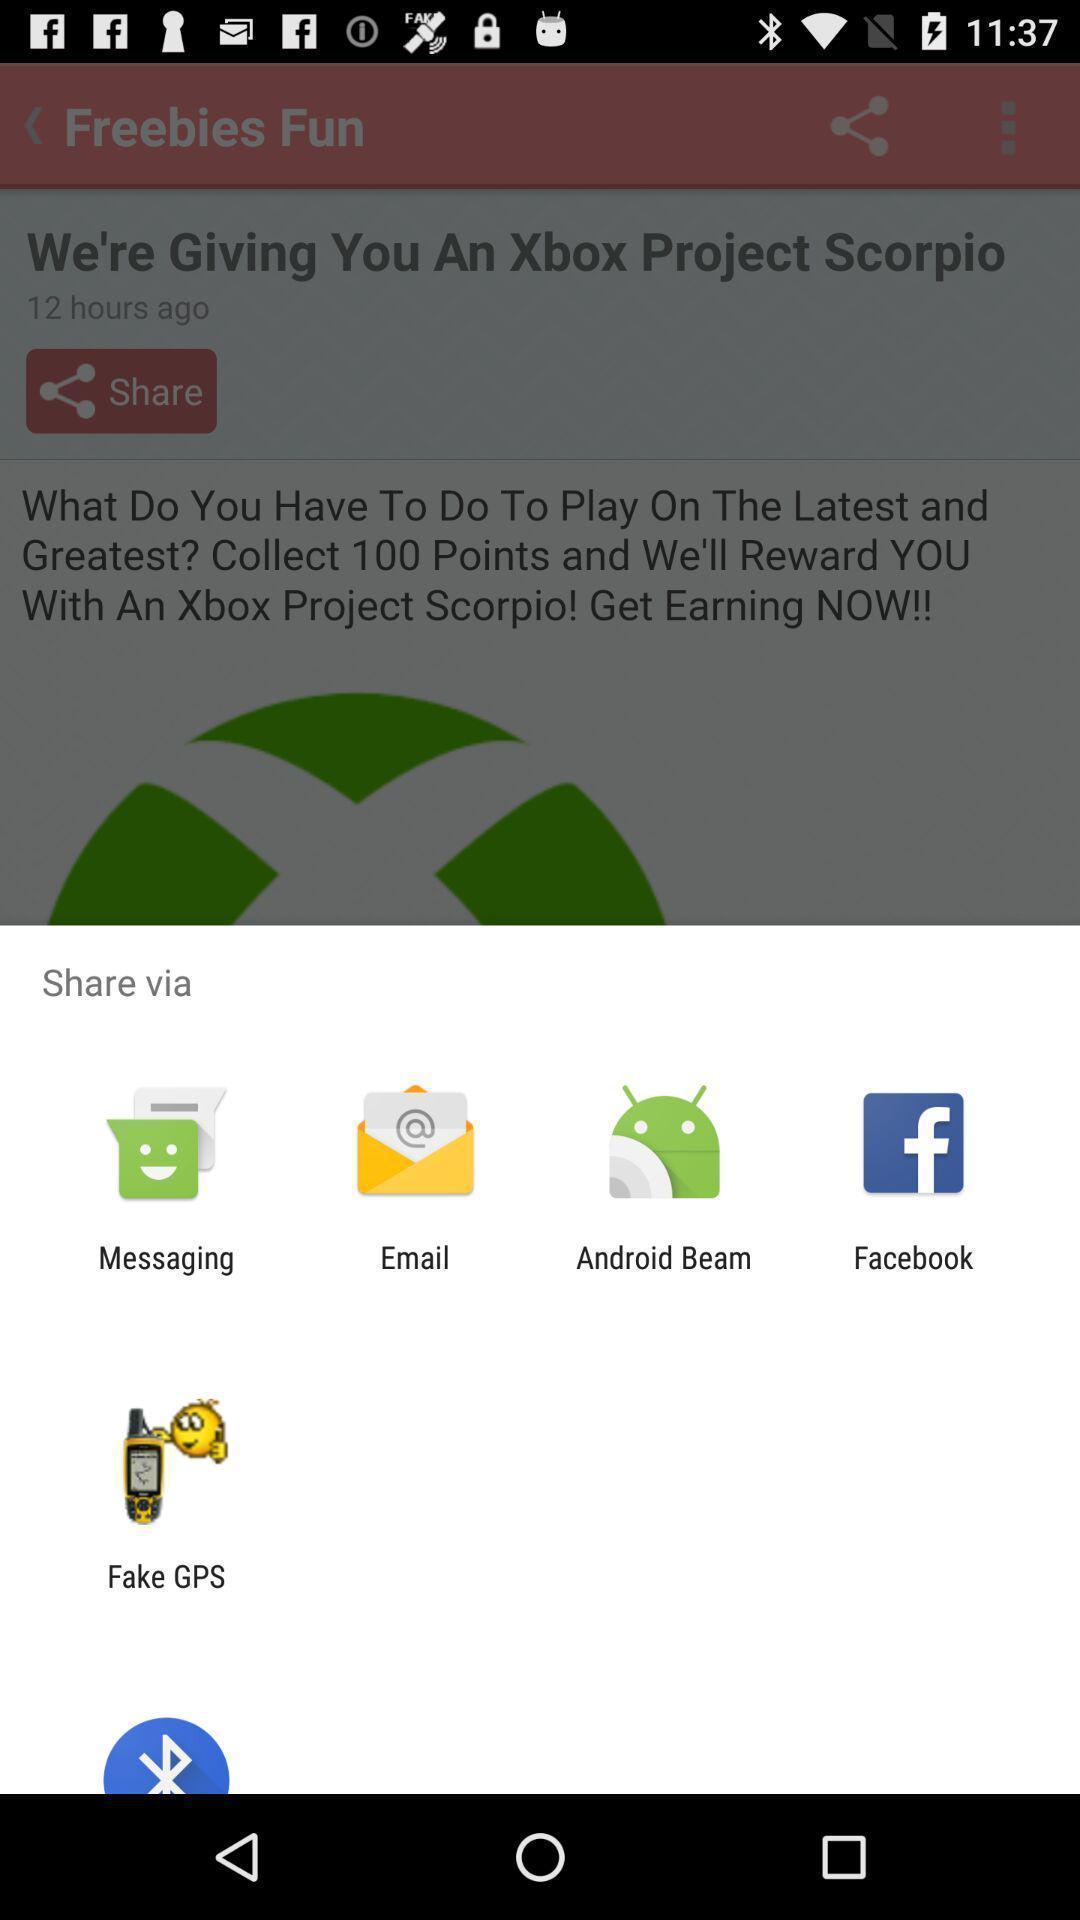Please provide a description for this image. Pop up showing various apps to share. 